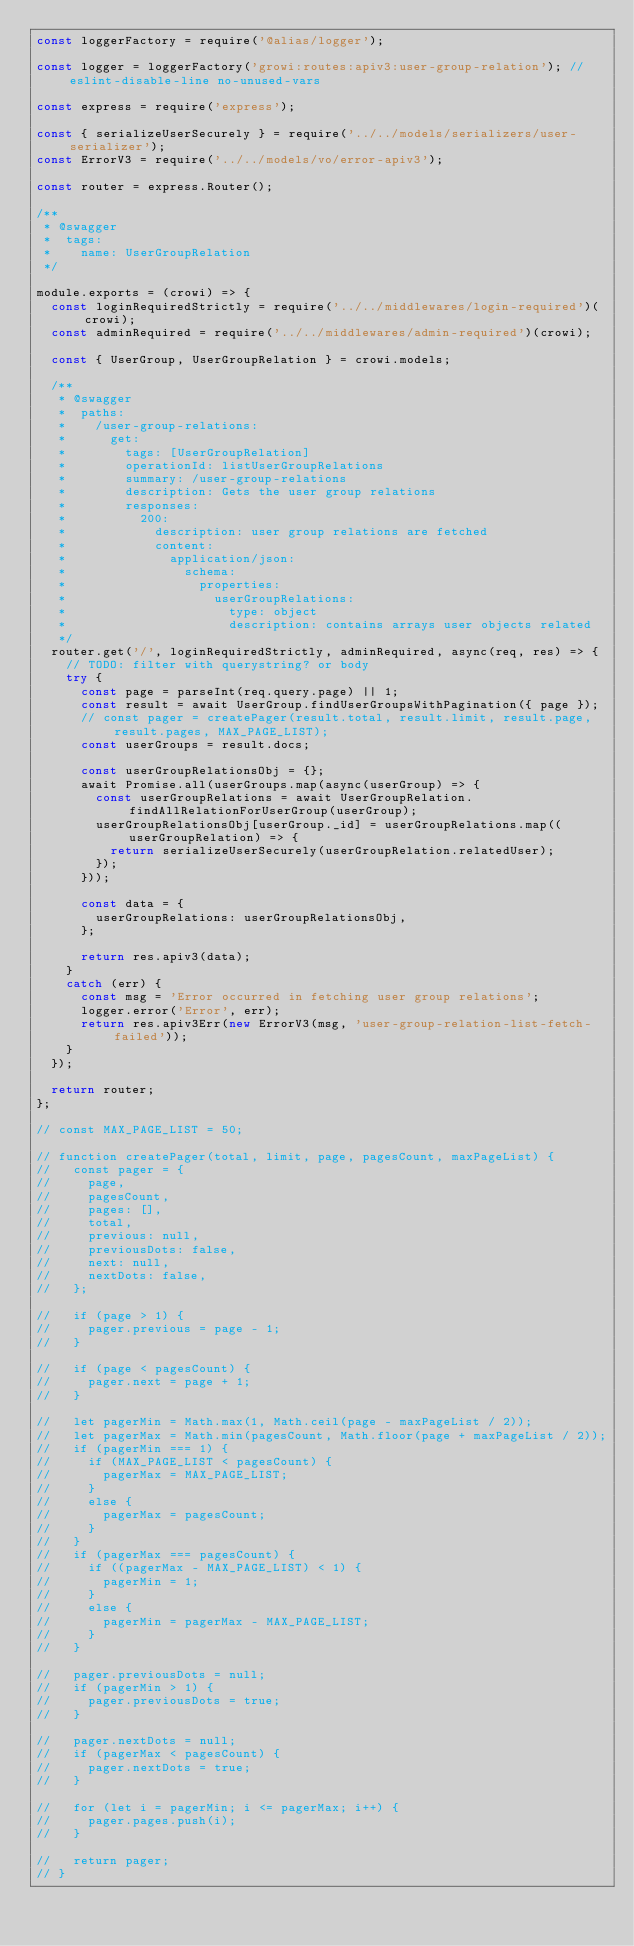Convert code to text. <code><loc_0><loc_0><loc_500><loc_500><_JavaScript_>const loggerFactory = require('@alias/logger');

const logger = loggerFactory('growi:routes:apiv3:user-group-relation'); // eslint-disable-line no-unused-vars

const express = require('express');

const { serializeUserSecurely } = require('../../models/serializers/user-serializer');
const ErrorV3 = require('../../models/vo/error-apiv3');

const router = express.Router();

/**
 * @swagger
 *  tags:
 *    name: UserGroupRelation
 */

module.exports = (crowi) => {
  const loginRequiredStrictly = require('../../middlewares/login-required')(crowi);
  const adminRequired = require('../../middlewares/admin-required')(crowi);

  const { UserGroup, UserGroupRelation } = crowi.models;

  /**
   * @swagger
   *  paths:
   *    /user-group-relations:
   *      get:
   *        tags: [UserGroupRelation]
   *        operationId: listUserGroupRelations
   *        summary: /user-group-relations
   *        description: Gets the user group relations
   *        responses:
   *          200:
   *            description: user group relations are fetched
   *            content:
   *              application/json:
   *                schema:
   *                  properties:
   *                    userGroupRelations:
   *                      type: object
   *                      description: contains arrays user objects related
   */
  router.get('/', loginRequiredStrictly, adminRequired, async(req, res) => {
    // TODO: filter with querystring? or body
    try {
      const page = parseInt(req.query.page) || 1;
      const result = await UserGroup.findUserGroupsWithPagination({ page });
      // const pager = createPager(result.total, result.limit, result.page, result.pages, MAX_PAGE_LIST);
      const userGroups = result.docs;

      const userGroupRelationsObj = {};
      await Promise.all(userGroups.map(async(userGroup) => {
        const userGroupRelations = await UserGroupRelation.findAllRelationForUserGroup(userGroup);
        userGroupRelationsObj[userGroup._id] = userGroupRelations.map((userGroupRelation) => {
          return serializeUserSecurely(userGroupRelation.relatedUser);
        });
      }));

      const data = {
        userGroupRelations: userGroupRelationsObj,
      };

      return res.apiv3(data);
    }
    catch (err) {
      const msg = 'Error occurred in fetching user group relations';
      logger.error('Error', err);
      return res.apiv3Err(new ErrorV3(msg, 'user-group-relation-list-fetch-failed'));
    }
  });

  return router;
};

// const MAX_PAGE_LIST = 50;

// function createPager(total, limit, page, pagesCount, maxPageList) {
//   const pager = {
//     page,
//     pagesCount,
//     pages: [],
//     total,
//     previous: null,
//     previousDots: false,
//     next: null,
//     nextDots: false,
//   };

//   if (page > 1) {
//     pager.previous = page - 1;
//   }

//   if (page < pagesCount) {
//     pager.next = page + 1;
//   }

//   let pagerMin = Math.max(1, Math.ceil(page - maxPageList / 2));
//   let pagerMax = Math.min(pagesCount, Math.floor(page + maxPageList / 2));
//   if (pagerMin === 1) {
//     if (MAX_PAGE_LIST < pagesCount) {
//       pagerMax = MAX_PAGE_LIST;
//     }
//     else {
//       pagerMax = pagesCount;
//     }
//   }
//   if (pagerMax === pagesCount) {
//     if ((pagerMax - MAX_PAGE_LIST) < 1) {
//       pagerMin = 1;
//     }
//     else {
//       pagerMin = pagerMax - MAX_PAGE_LIST;
//     }
//   }

//   pager.previousDots = null;
//   if (pagerMin > 1) {
//     pager.previousDots = true;
//   }

//   pager.nextDots = null;
//   if (pagerMax < pagesCount) {
//     pager.nextDots = true;
//   }

//   for (let i = pagerMin; i <= pagerMax; i++) {
//     pager.pages.push(i);
//   }

//   return pager;
// }
</code> 